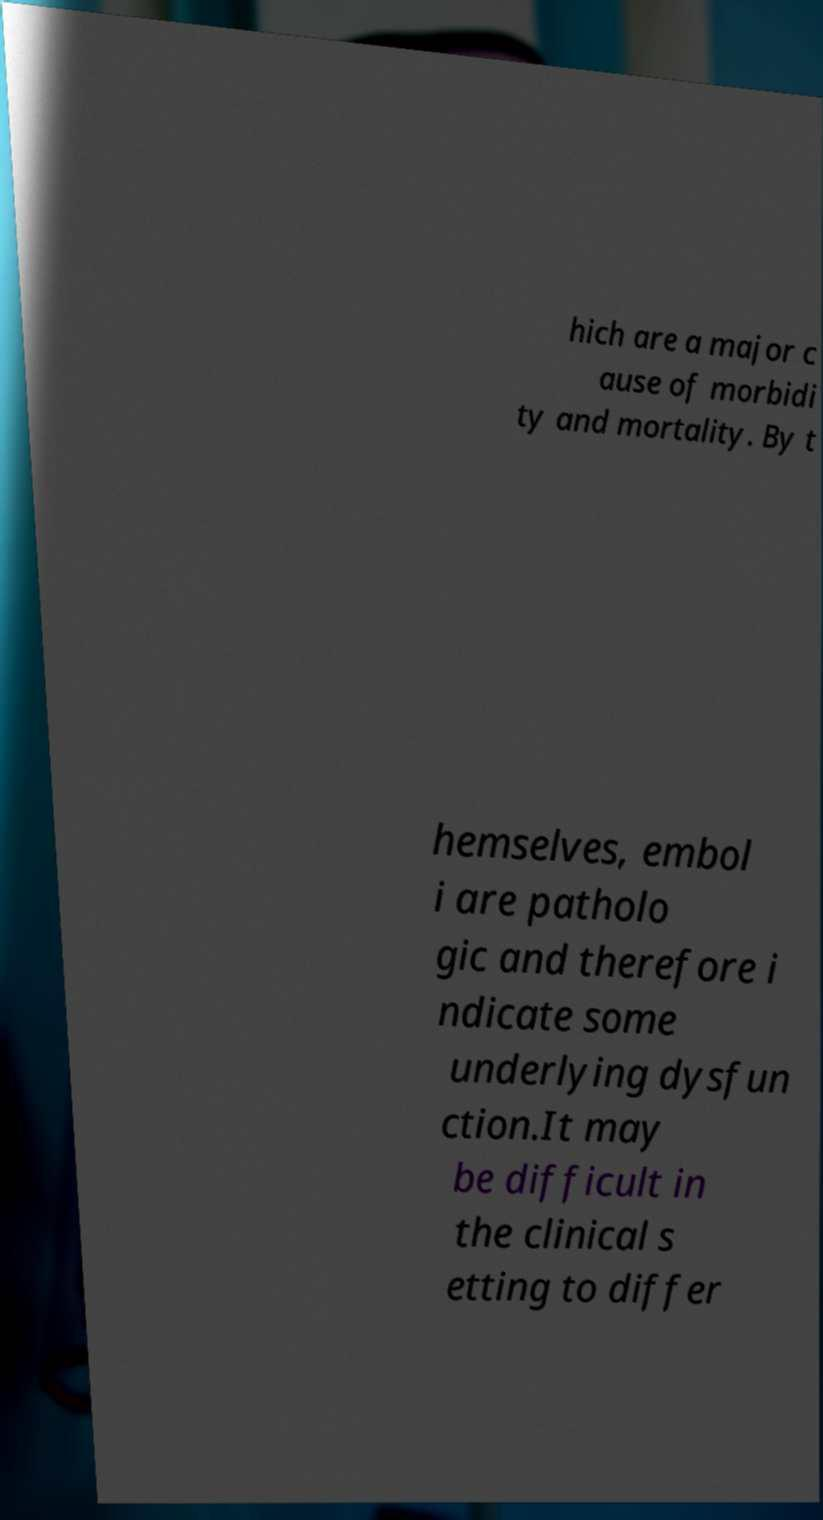What messages or text are displayed in this image? I need them in a readable, typed format. hich are a major c ause of morbidi ty and mortality. By t hemselves, embol i are patholo gic and therefore i ndicate some underlying dysfun ction.It may be difficult in the clinical s etting to differ 